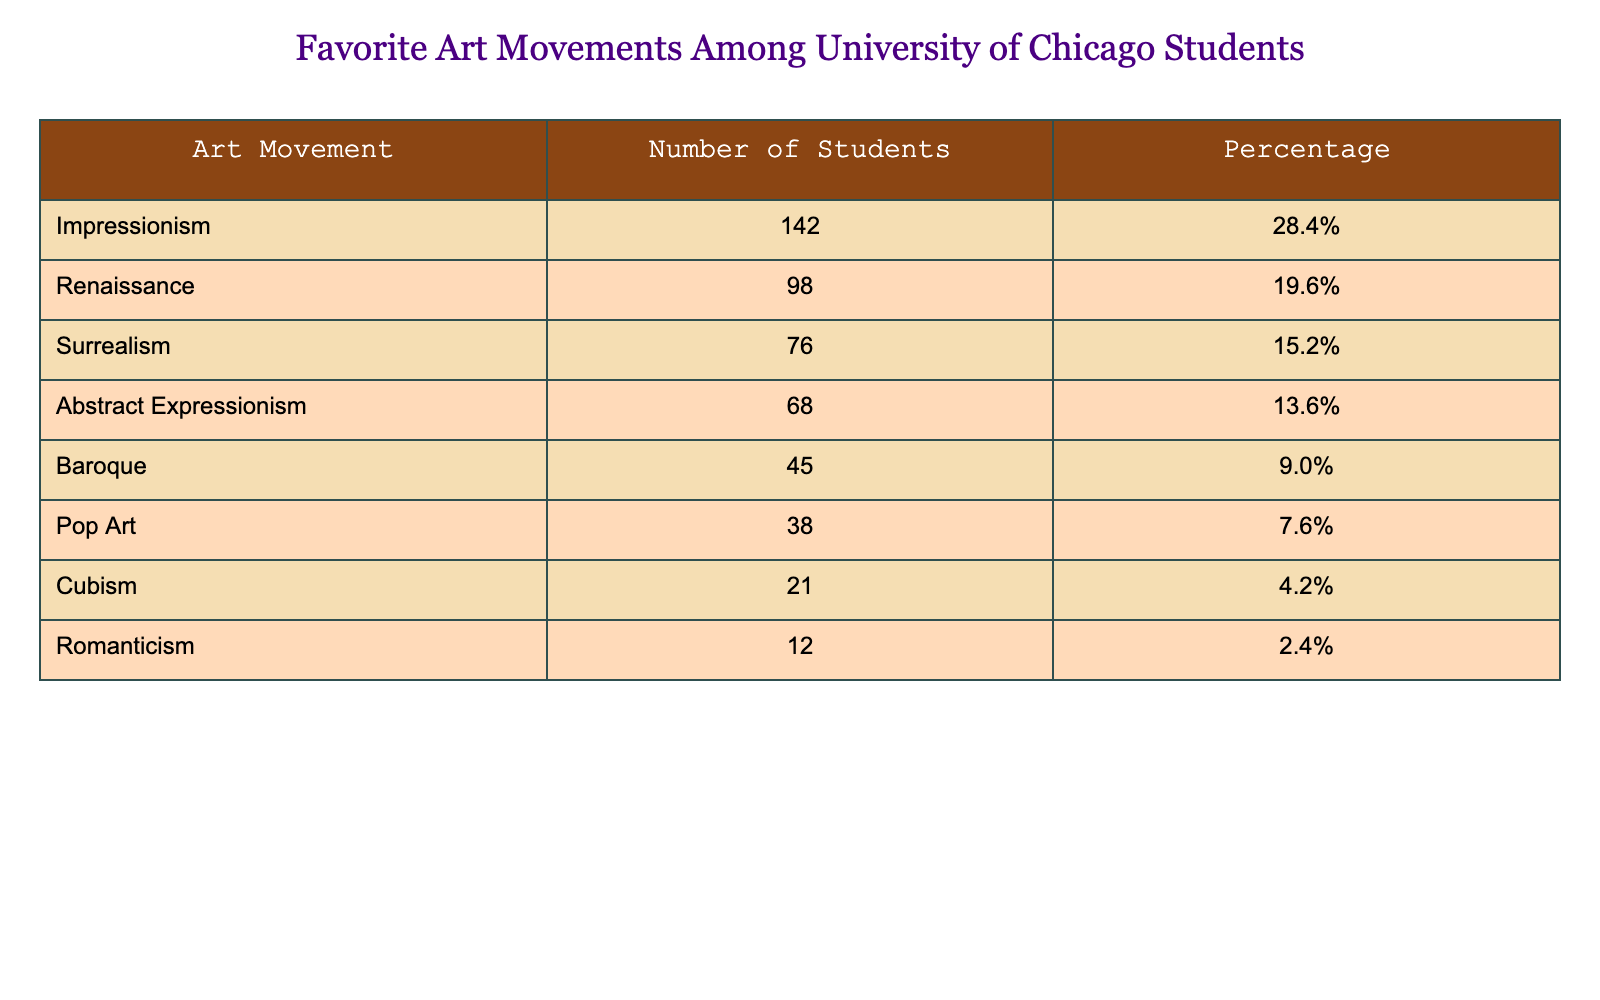What is the most favorite art movement among University of Chicago students? Looking at the "Number of Students" column, Impressionism has the highest value of 142, indicating it is the most favorite art movement.
Answer: Impressionism How many students favored Renaissance as an art movement? The "Number of Students" for Renaissance is given as 98 in the table.
Answer: 98 What percentage of students selected Abstract Expressionism? The percentage of students for Abstract Expressionism is listed as 13.6% in the table.
Answer: 13.6% Which art movement had the least number of student supporters? In the "Number of Students" column, Romanticism has the lowest number with 12, indicating it had the least support.
Answer: Romanticism What is the combined total number of students who favored Pop Art and Cubism? Pop Art has 38 students and Cubism has 21 students; adding these gives 38 + 21 = 59 for the total combined students.
Answer: 59 Is the number of students who favored Surrealism greater than those who favored Cubism? Surrealism has 76 students while Cubism has 21 students; since 76 is greater than 21, the statement is true.
Answer: Yes What percentage of students preferred art movements other than Cubism? The total percentage of students is 100%. For Cubism, the percentage is 4.2%. Thus, 100% - 4.2% = 95.8% preferred other movements.
Answer: 95.8% If we combine the number of students who favored Impressionism and Renaissance, what is the sum? The number of students for Impressionism is 142 and for Renaissance is 98, and their sum is 142 + 98 = 240.
Answer: 240 Which art movement has a percentage closest to 10%? Baroque has a percentage of 9%, which is closest to 10% compared to the other movements listed.
Answer: Baroque What is the average percentage of students' preferences for Abstract Expressionism and Surrealism? Abstract Expressionism has a percentage of 13.6% and Surrealism has 15.2%. The average is (13.6 + 15.2) / 2 = 14.4%.
Answer: 14.4% 